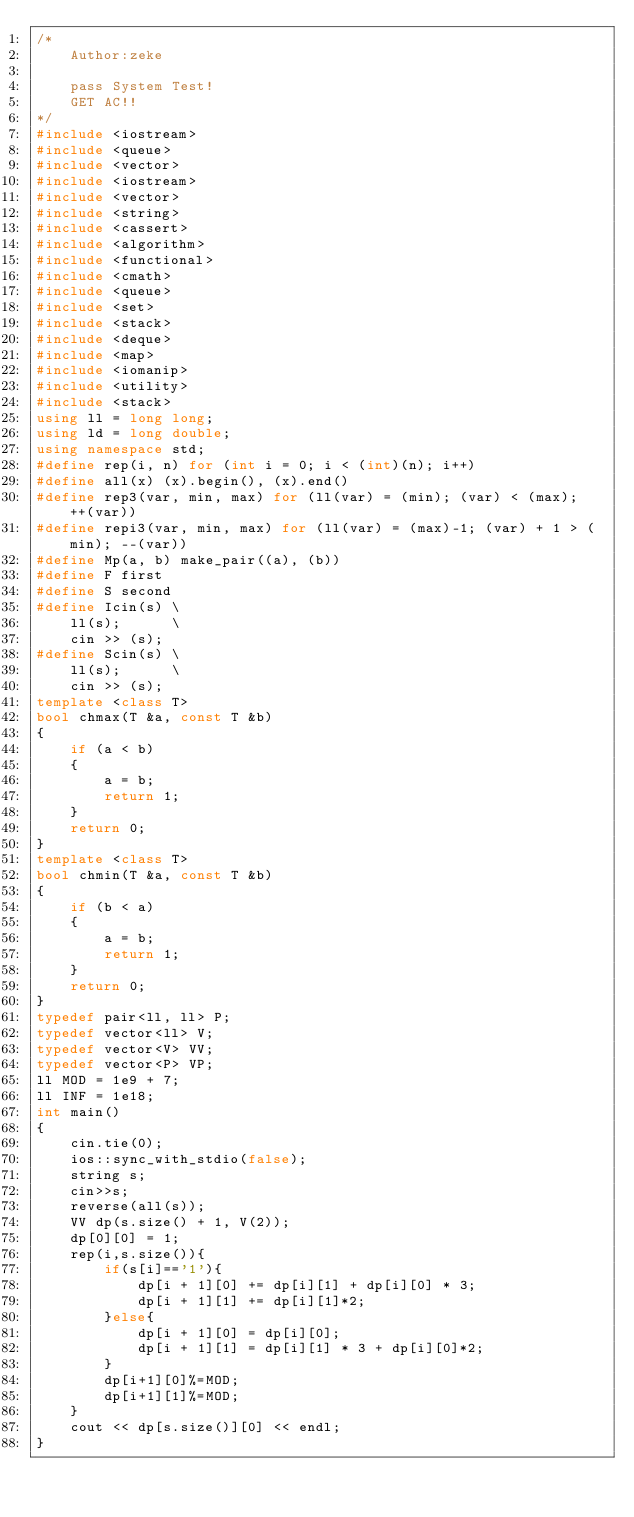Convert code to text. <code><loc_0><loc_0><loc_500><loc_500><_C++_>/*
    Author:zeke
    
    pass System Test!
    GET AC!!
*/
#include <iostream>
#include <queue>
#include <vector>
#include <iostream>
#include <vector>
#include <string>
#include <cassert>
#include <algorithm>
#include <functional>
#include <cmath>
#include <queue>
#include <set>
#include <stack>
#include <deque>
#include <map>
#include <iomanip>
#include <utility>
#include <stack>
using ll = long long;
using ld = long double;
using namespace std;
#define rep(i, n) for (int i = 0; i < (int)(n); i++)
#define all(x) (x).begin(), (x).end()
#define rep3(var, min, max) for (ll(var) = (min); (var) < (max); ++(var))
#define repi3(var, min, max) for (ll(var) = (max)-1; (var) + 1 > (min); --(var))
#define Mp(a, b) make_pair((a), (b))
#define F first
#define S second
#define Icin(s) \
    ll(s);      \
    cin >> (s);
#define Scin(s) \
    ll(s);      \
    cin >> (s);
template <class T>
bool chmax(T &a, const T &b)
{
    if (a < b)
    {
        a = b;
        return 1;
    }
    return 0;
}
template <class T>
bool chmin(T &a, const T &b)
{
    if (b < a)
    {
        a = b;
        return 1;
    }
    return 0;
}
typedef pair<ll, ll> P;
typedef vector<ll> V;
typedef vector<V> VV;
typedef vector<P> VP;
ll MOD = 1e9 + 7;
ll INF = 1e18;
int main()
{
    cin.tie(0);
    ios::sync_with_stdio(false);
    string s;
    cin>>s;
    reverse(all(s));
    VV dp(s.size() + 1, V(2));
    dp[0][0] = 1;
    rep(i,s.size()){
        if(s[i]=='1'){
            dp[i + 1][0] += dp[i][1] + dp[i][0] * 3;
            dp[i + 1][1] += dp[i][1]*2;
        }else{
            dp[i + 1][0] = dp[i][0];
            dp[i + 1][1] = dp[i][1] * 3 + dp[i][0]*2;
        }
        dp[i+1][0]%=MOD;
        dp[i+1][1]%=MOD;
    }
    cout << dp[s.size()][0] << endl;
}</code> 